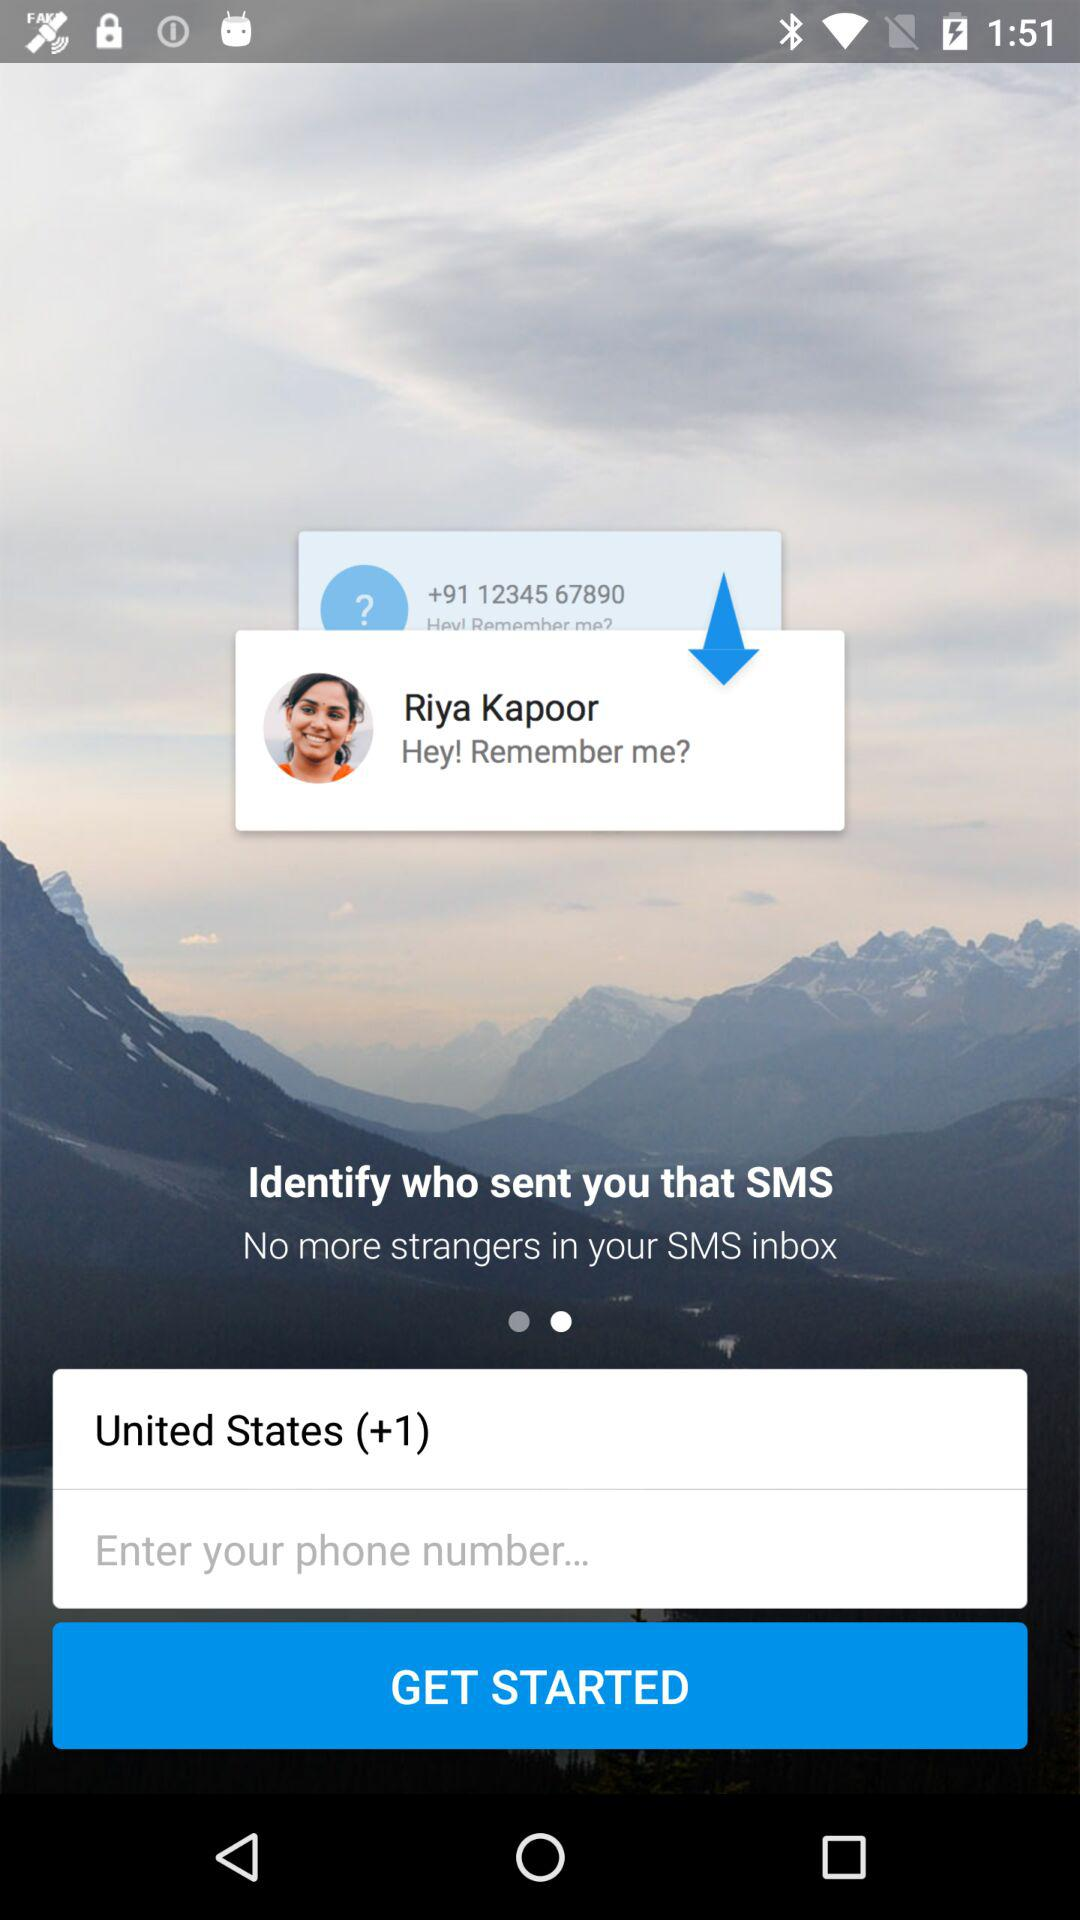What's the name of the girl? The girl's name is Riya Kapoor. 